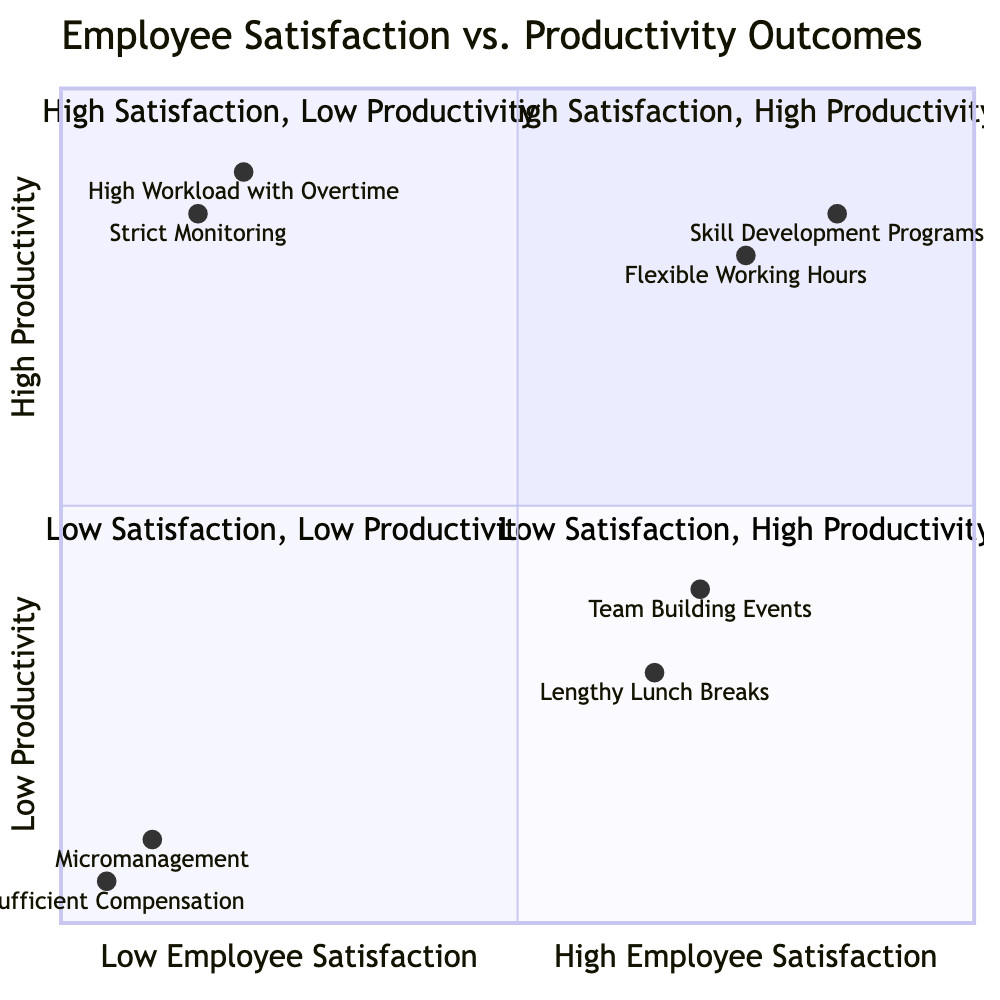What strategies fall into the "High Satisfaction, High Productivity" quadrant? By looking at the diagram, the "High Satisfaction, High Productivity" quadrant lists two strategies: "Flexible Working Hours" and "Skill Development Programs".
Answer: Flexible Working Hours, Skill Development Programs What is the number of strategies in the "Low Employee Satisfaction, Low Productivity" quadrant? The "Low Employee Satisfaction, Low Productivity" quadrant contains two strategies: "Micromanagement" and "Insufficient Compensation". Thus, the count is 2.
Answer: 2 Which strategy has the lowest productivity outcome? Checking the productivity values in the quadrants, "Insufficient Compensation" has the lowest productivity score at 0.05.
Answer: Insufficient Compensation Which quadrant contains strategies that potentially harm employee morale? The "Low Satisfaction, High Productivity" quadrant features two strategies: "High Workload with Overtime" and "Strict Monitoring". Both are linked to poor employee morale despite high productivity.
Answer: Low Satisfaction, High Productivity What is the productivity score of "Team Building Events"? From the quadrant data, "Team Building Events" is located in the "High Satisfaction, Low Productivity" quadrant, and its productivity score is 0.4.
Answer: 0.4 Which strategy leads to high productivity but low satisfaction? The strategy "High Workload with Overtime," found in the "Low Satisfaction, High Productivity" quadrant, results in high productivity but typically decreases employee satisfaction.
Answer: High Workload with Overtime What is the relationship between flexible working hours and skill development programs regarding both satisfaction and productivity? Both strategies appear in the same quadrant ("High Satisfaction, High Productivity") with high scores of satisfaction (0.75 for Flexible Working Hours and 0.85 for Skill Development Programs) and high productivity (0.8 for Flexible Working Hours and 0.85 for Skill Development Programs). Hence, they are positively correlated, indicating that the use of either strategy can enhance both employee satisfaction and productivity.
Answer: Positive correlation Which quadrant contains employees exposed to micromanagement? The strategy "Micromanagement" is situated in the "Low Satisfaction, Low Productivity" quadrant, illustrating that employees exposed to this management style experience both low satisfaction and low productivity.
Answer: Low Satisfaction, Low Productivity How do strategies in the "High Satisfaction, Low Productivity" quadrant impact productivity? Strategies like "Team Building Events" and "Lengthy Lunch Breaks" in this quadrant enhance employee satisfaction but lead to decreased productivity outcomes, indicating that increasing satisfaction can sometimes lead to lower productivity.
Answer: Decreased productivity 